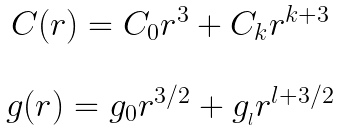Convert formula to latex. <formula><loc_0><loc_0><loc_500><loc_500>\begin{array} { c } C ( r ) = C _ { 0 } r ^ { 3 } + C _ { k } r ^ { k + 3 } \\ \\ g ( r ) = g _ { 0 } r ^ { 3 / 2 } + g _ { _ { l } } r ^ { l + 3 / 2 } \end{array}</formula> 